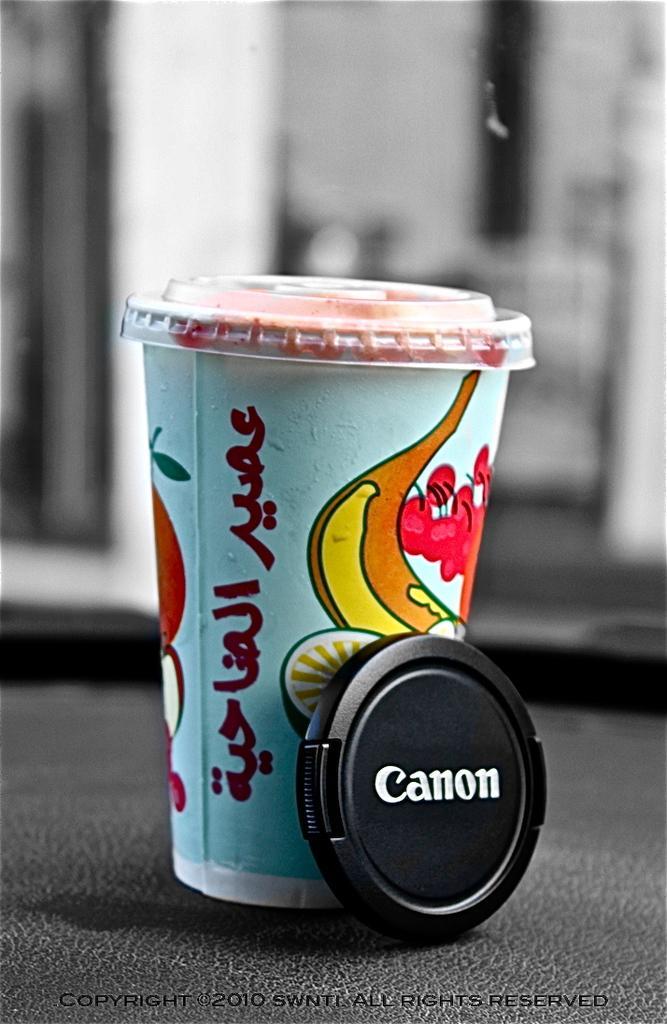Describe this image in one or two sentences. In this picture there is a disposable glass and in the background there is a window 